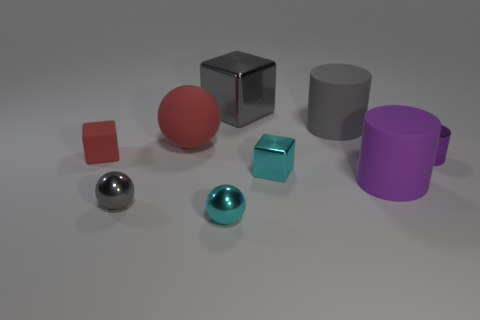Is the shape of the big gray rubber thing the same as the big red thing? No, the shapes are not the same. The big gray object is cylindrical, while the big red object has a cubic form. Despite both being geometrical shapes, their dimensions and contour lines are distinctly different. 